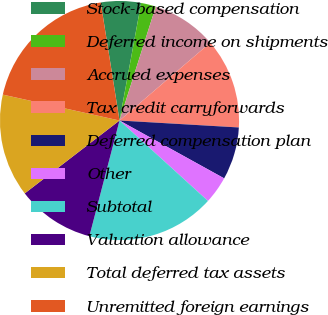Convert chart to OTSL. <chart><loc_0><loc_0><loc_500><loc_500><pie_chart><fcel>Stock-based compensation<fcel>Deferred income on shipments<fcel>Accrued expenses<fcel>Tax credit carryforwards<fcel>Deferred compensation plan<fcel>Other<fcel>Subtotal<fcel>Valuation allowance<fcel>Total deferred tax assets<fcel>Unremitted foreign earnings<nl><fcel>5.41%<fcel>2.01%<fcel>8.81%<fcel>12.21%<fcel>7.11%<fcel>3.71%<fcel>17.31%<fcel>10.51%<fcel>13.91%<fcel>19.01%<nl></chart> 